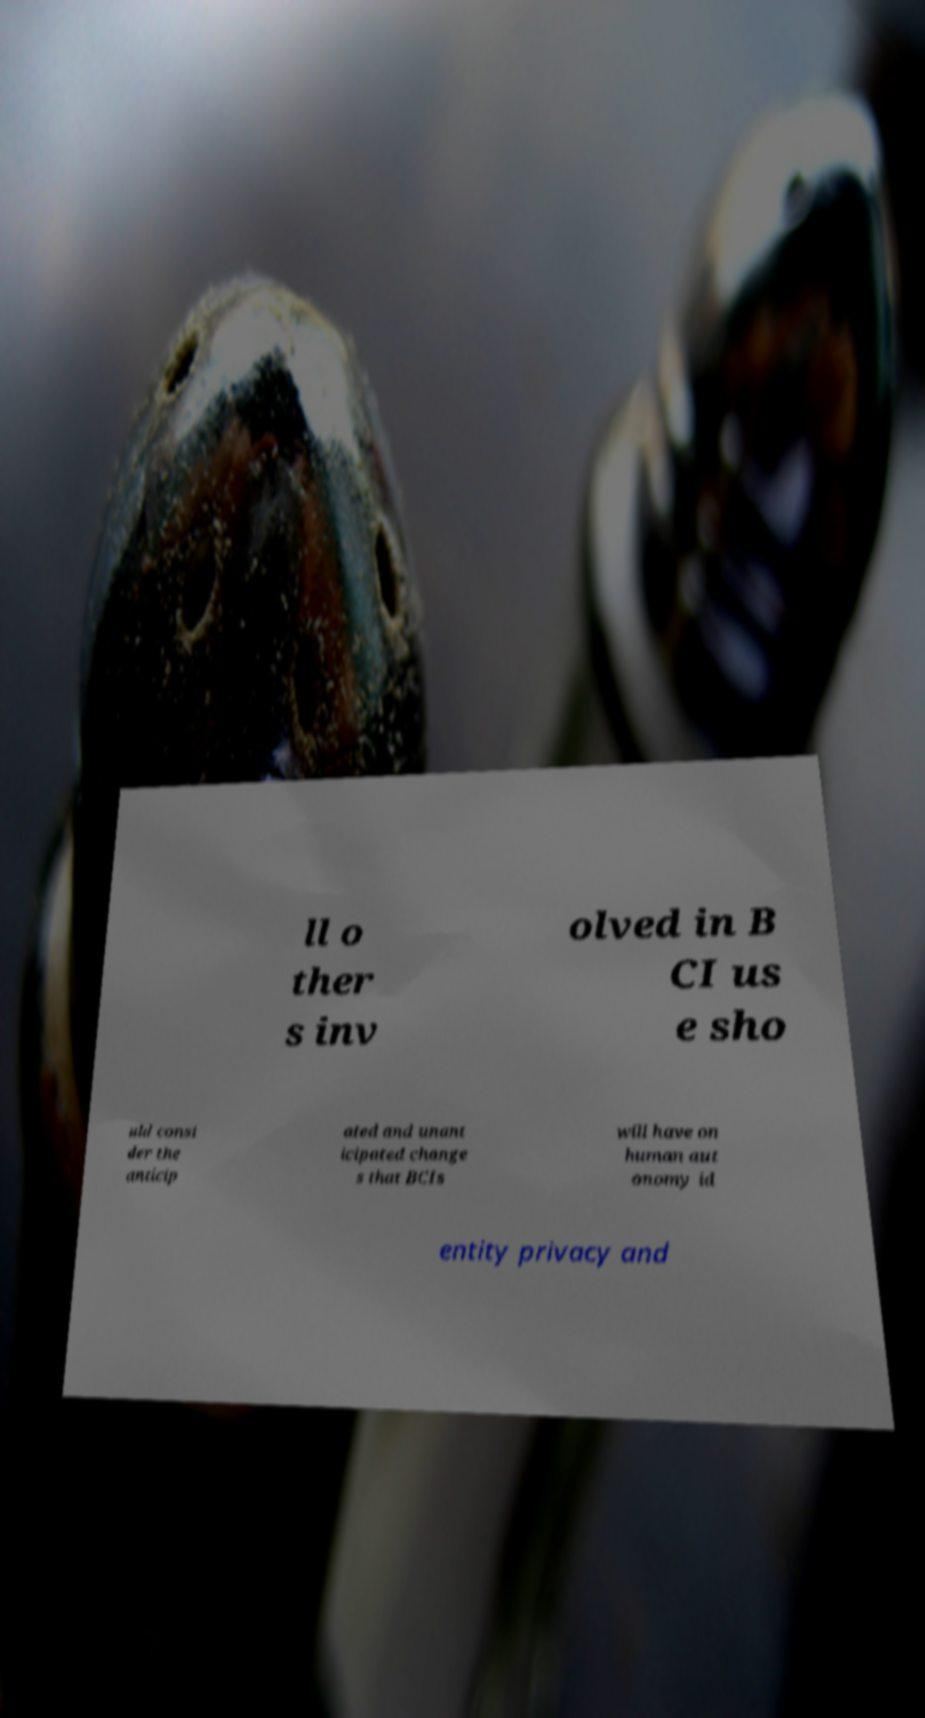Can you accurately transcribe the text from the provided image for me? ll o ther s inv olved in B CI us e sho uld consi der the anticip ated and unant icipated change s that BCIs will have on human aut onomy id entity privacy and 